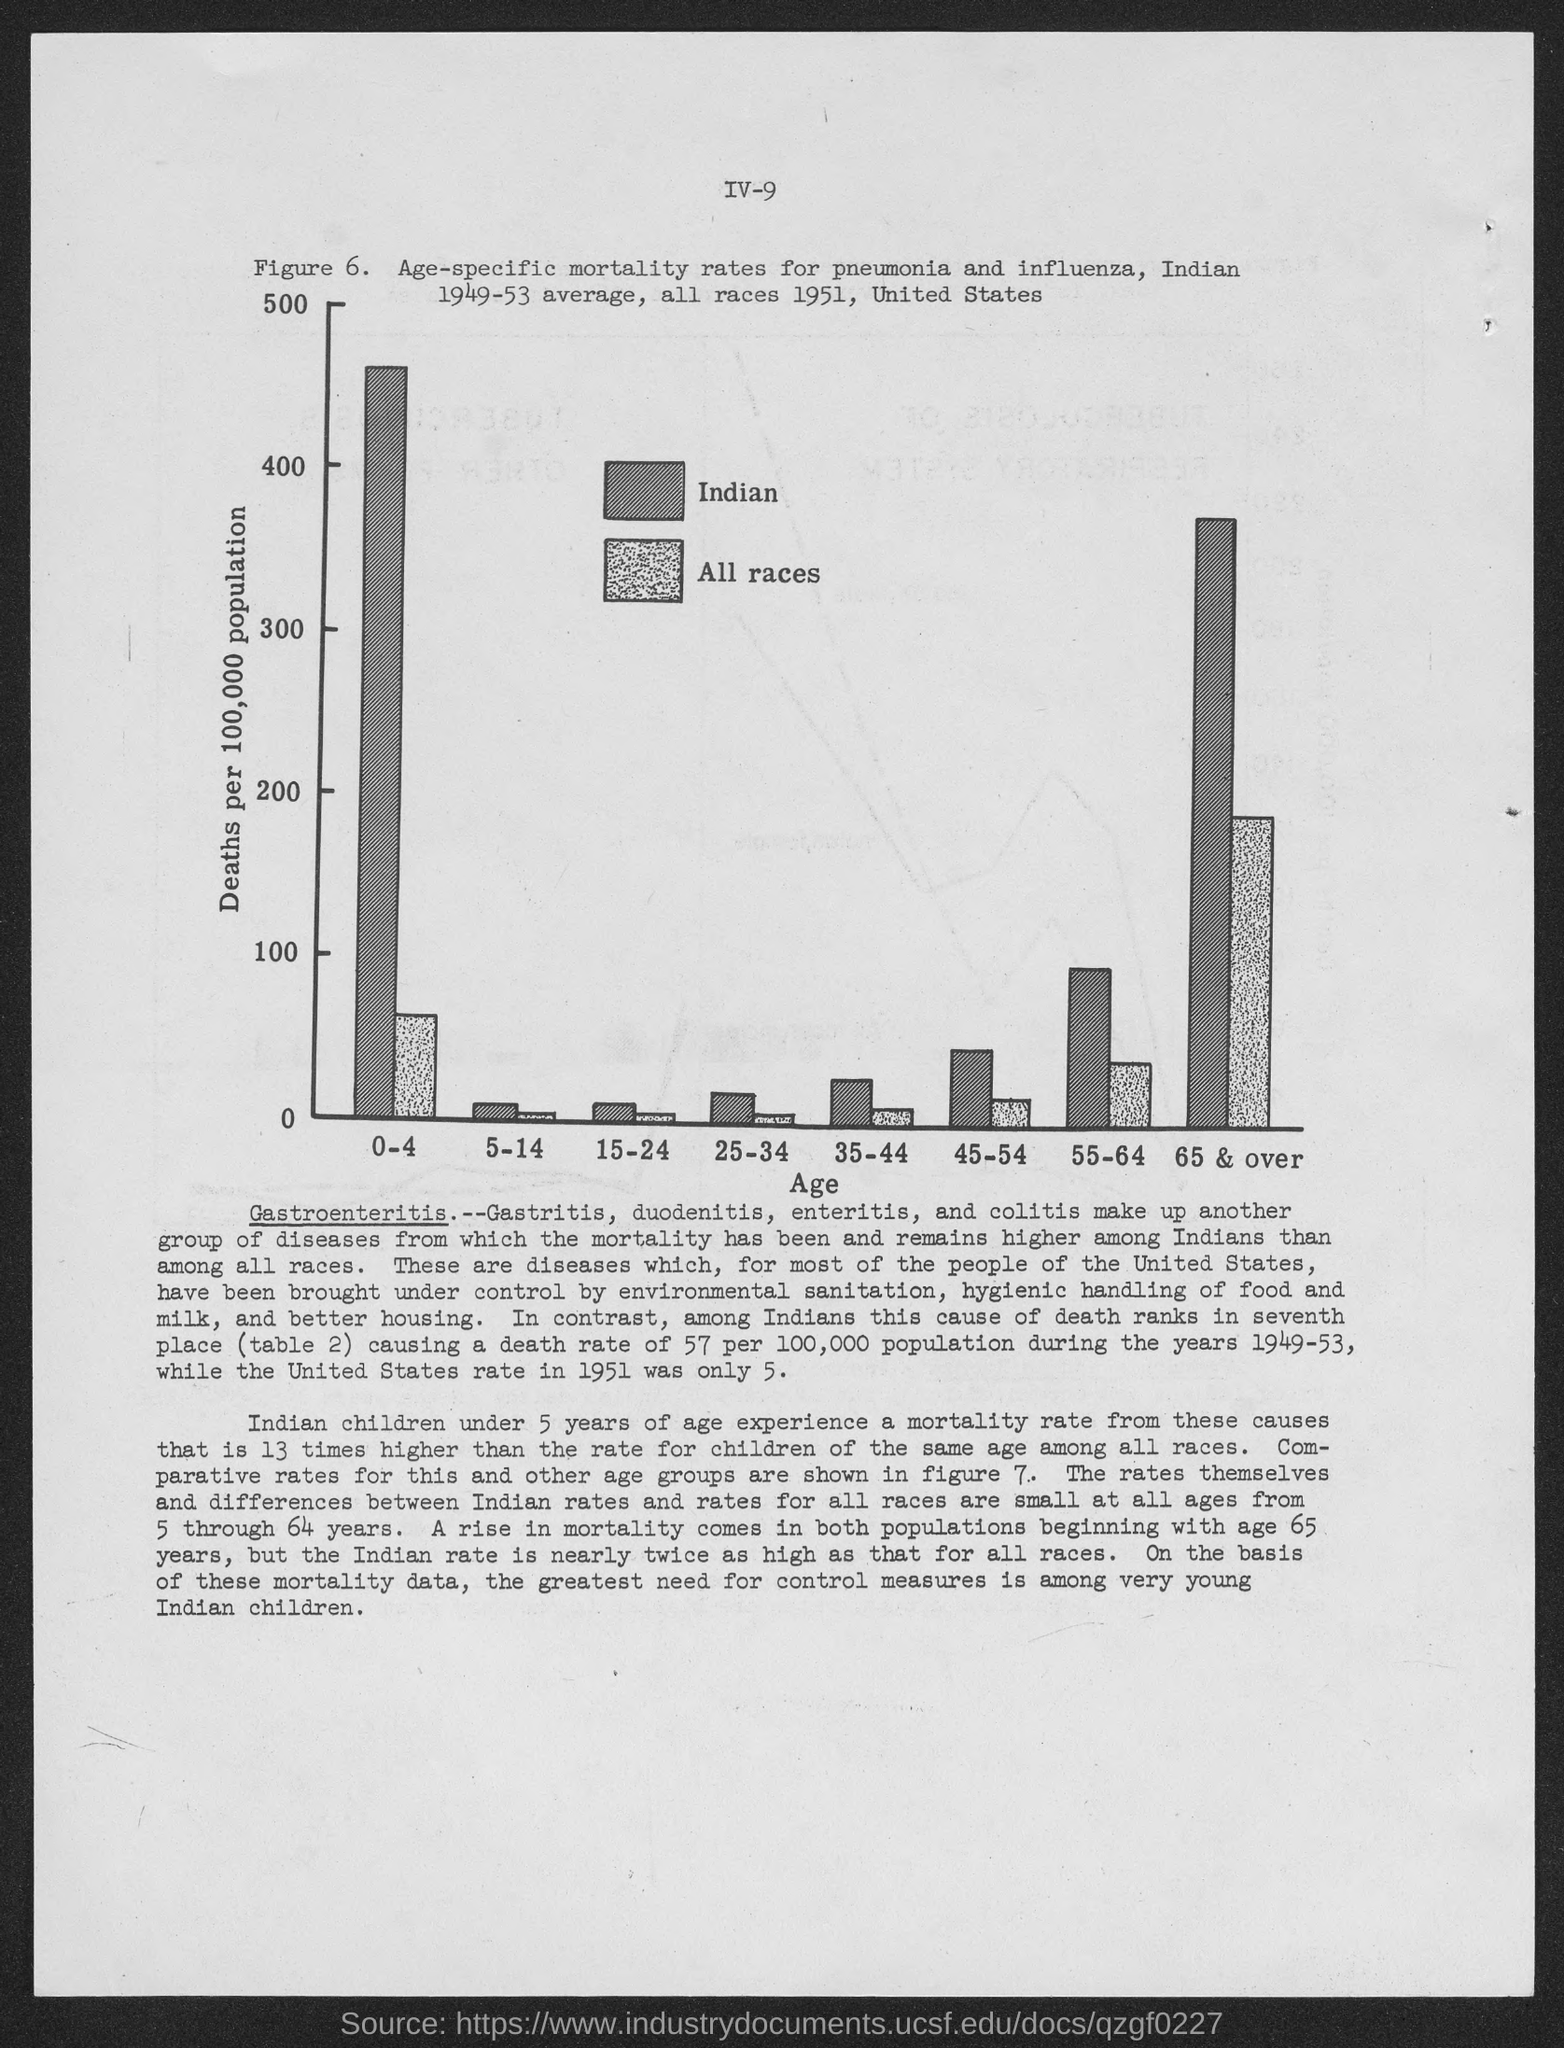What is given in the x-axis of the figure?
Your answer should be very brief. Age. What is the figure no.?
Your response must be concise. 6. 